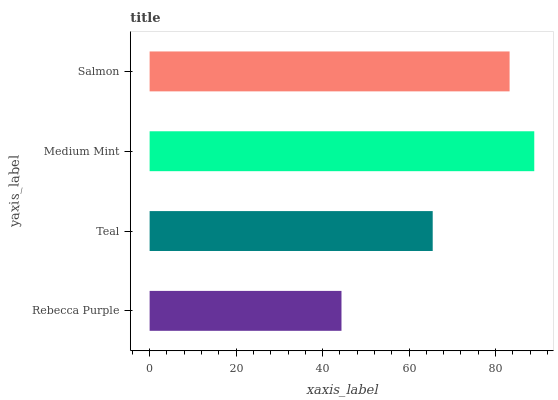Is Rebecca Purple the minimum?
Answer yes or no. Yes. Is Medium Mint the maximum?
Answer yes or no. Yes. Is Teal the minimum?
Answer yes or no. No. Is Teal the maximum?
Answer yes or no. No. Is Teal greater than Rebecca Purple?
Answer yes or no. Yes. Is Rebecca Purple less than Teal?
Answer yes or no. Yes. Is Rebecca Purple greater than Teal?
Answer yes or no. No. Is Teal less than Rebecca Purple?
Answer yes or no. No. Is Salmon the high median?
Answer yes or no. Yes. Is Teal the low median?
Answer yes or no. Yes. Is Rebecca Purple the high median?
Answer yes or no. No. Is Salmon the low median?
Answer yes or no. No. 